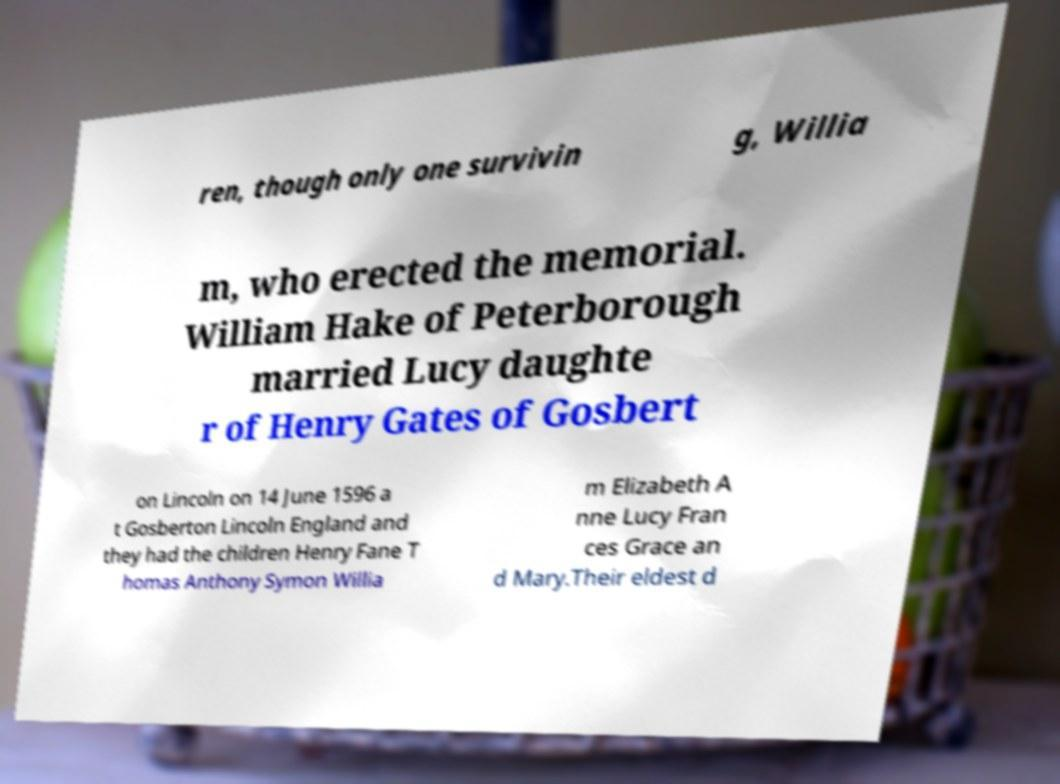What messages or text are displayed in this image? I need them in a readable, typed format. ren, though only one survivin g, Willia m, who erected the memorial. William Hake of Peterborough married Lucy daughte r of Henry Gates of Gosbert on Lincoln on 14 June 1596 a t Gosberton Lincoln England and they had the children Henry Fane T homas Anthony Symon Willia m Elizabeth A nne Lucy Fran ces Grace an d Mary.Their eldest d 